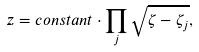Convert formula to latex. <formula><loc_0><loc_0><loc_500><loc_500>z = c o n s t a n t \cdot \prod _ { j } \sqrt { \zeta - \zeta _ { j } } ,</formula> 